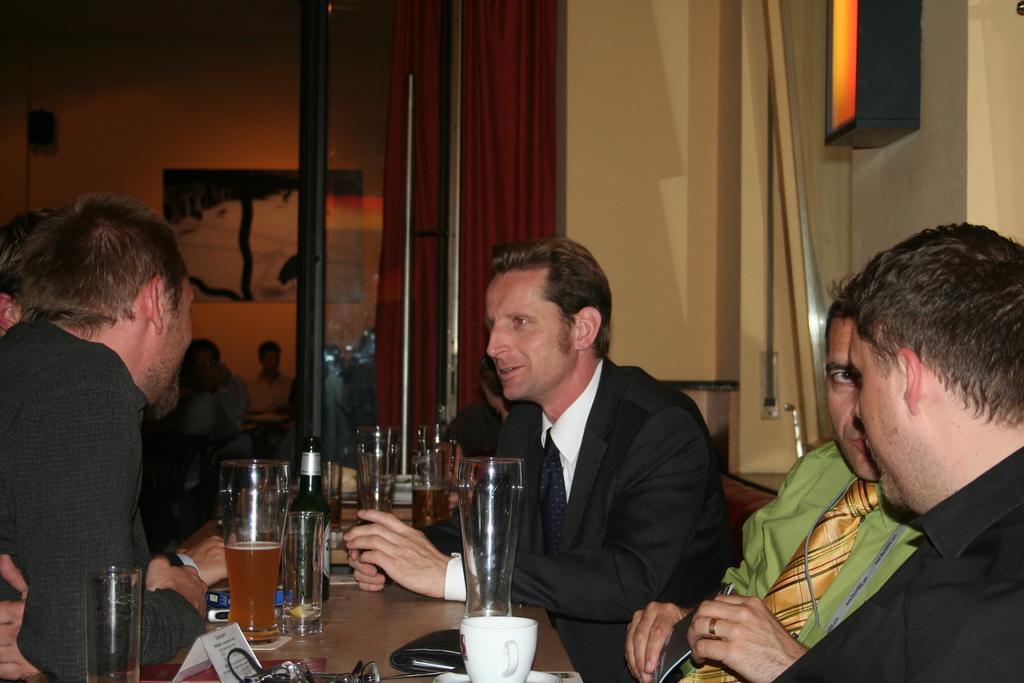In one or two sentences, can you explain what this image depicts? In this picture, In the middle there is a table in black color and there are some glasses and bottles on the table, There are some people sitting on the chairs around the table, in the background there is a red color curtain and there is a wall which is in yellow color. 